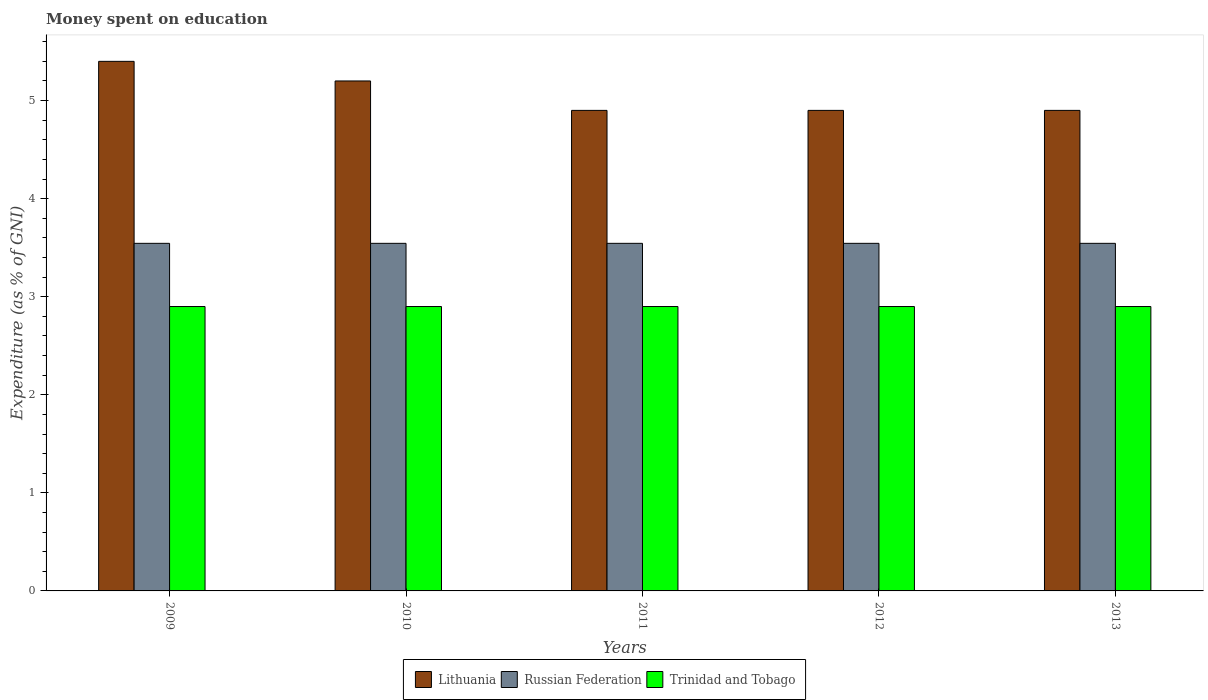How many groups of bars are there?
Offer a very short reply. 5. Are the number of bars on each tick of the X-axis equal?
Your answer should be very brief. Yes. What is the label of the 4th group of bars from the left?
Your response must be concise. 2012. In how many cases, is the number of bars for a given year not equal to the number of legend labels?
Provide a short and direct response. 0. Across all years, what is the maximum amount of money spent on education in Trinidad and Tobago?
Offer a terse response. 2.9. Across all years, what is the minimum amount of money spent on education in Russian Federation?
Ensure brevity in your answer.  3.54. What is the total amount of money spent on education in Trinidad and Tobago in the graph?
Provide a succinct answer. 14.5. What is the difference between the amount of money spent on education in Lithuania in 2010 and that in 2011?
Give a very brief answer. 0.3. What is the difference between the amount of money spent on education in Lithuania in 2010 and the amount of money spent on education in Russian Federation in 2012?
Your answer should be very brief. 1.66. In the year 2013, what is the difference between the amount of money spent on education in Lithuania and amount of money spent on education in Russian Federation?
Offer a terse response. 1.36. In how many years, is the amount of money spent on education in Trinidad and Tobago greater than 3.6 %?
Ensure brevity in your answer.  0. What is the ratio of the amount of money spent on education in Russian Federation in 2011 to that in 2013?
Ensure brevity in your answer.  1. In how many years, is the amount of money spent on education in Lithuania greater than the average amount of money spent on education in Lithuania taken over all years?
Offer a very short reply. 2. Is the sum of the amount of money spent on education in Trinidad and Tobago in 2012 and 2013 greater than the maximum amount of money spent on education in Lithuania across all years?
Keep it short and to the point. Yes. What does the 2nd bar from the left in 2010 represents?
Offer a very short reply. Russian Federation. What does the 3rd bar from the right in 2013 represents?
Your answer should be very brief. Lithuania. How many bars are there?
Ensure brevity in your answer.  15. How many years are there in the graph?
Keep it short and to the point. 5. Are the values on the major ticks of Y-axis written in scientific E-notation?
Give a very brief answer. No. Does the graph contain any zero values?
Your answer should be compact. No. Where does the legend appear in the graph?
Keep it short and to the point. Bottom center. What is the title of the graph?
Keep it short and to the point. Money spent on education. What is the label or title of the Y-axis?
Your response must be concise. Expenditure (as % of GNI). What is the Expenditure (as % of GNI) of Lithuania in 2009?
Offer a very short reply. 5.4. What is the Expenditure (as % of GNI) in Russian Federation in 2009?
Your answer should be very brief. 3.54. What is the Expenditure (as % of GNI) of Trinidad and Tobago in 2009?
Your answer should be compact. 2.9. What is the Expenditure (as % of GNI) in Russian Federation in 2010?
Make the answer very short. 3.54. What is the Expenditure (as % of GNI) in Trinidad and Tobago in 2010?
Offer a terse response. 2.9. What is the Expenditure (as % of GNI) of Lithuania in 2011?
Your answer should be compact. 4.9. What is the Expenditure (as % of GNI) in Russian Federation in 2011?
Your response must be concise. 3.54. What is the Expenditure (as % of GNI) in Russian Federation in 2012?
Provide a succinct answer. 3.54. What is the Expenditure (as % of GNI) of Lithuania in 2013?
Provide a short and direct response. 4.9. What is the Expenditure (as % of GNI) of Russian Federation in 2013?
Provide a succinct answer. 3.54. Across all years, what is the maximum Expenditure (as % of GNI) of Lithuania?
Your answer should be very brief. 5.4. Across all years, what is the maximum Expenditure (as % of GNI) in Russian Federation?
Provide a succinct answer. 3.54. Across all years, what is the minimum Expenditure (as % of GNI) of Russian Federation?
Your answer should be compact. 3.54. What is the total Expenditure (as % of GNI) in Lithuania in the graph?
Your answer should be very brief. 25.3. What is the total Expenditure (as % of GNI) of Russian Federation in the graph?
Provide a short and direct response. 17.72. What is the difference between the Expenditure (as % of GNI) in Russian Federation in 2009 and that in 2011?
Your response must be concise. 0. What is the difference between the Expenditure (as % of GNI) in Trinidad and Tobago in 2009 and that in 2011?
Make the answer very short. 0. What is the difference between the Expenditure (as % of GNI) of Lithuania in 2009 and that in 2012?
Your answer should be compact. 0.5. What is the difference between the Expenditure (as % of GNI) in Trinidad and Tobago in 2009 and that in 2012?
Your answer should be compact. 0. What is the difference between the Expenditure (as % of GNI) in Lithuania in 2009 and that in 2013?
Give a very brief answer. 0.5. What is the difference between the Expenditure (as % of GNI) in Trinidad and Tobago in 2009 and that in 2013?
Keep it short and to the point. 0. What is the difference between the Expenditure (as % of GNI) in Lithuania in 2010 and that in 2011?
Your response must be concise. 0.3. What is the difference between the Expenditure (as % of GNI) of Russian Federation in 2010 and that in 2011?
Make the answer very short. 0. What is the difference between the Expenditure (as % of GNI) of Lithuania in 2010 and that in 2013?
Give a very brief answer. 0.3. What is the difference between the Expenditure (as % of GNI) of Russian Federation in 2010 and that in 2013?
Give a very brief answer. 0. What is the difference between the Expenditure (as % of GNI) of Lithuania in 2011 and that in 2012?
Your answer should be very brief. 0. What is the difference between the Expenditure (as % of GNI) in Russian Federation in 2011 and that in 2012?
Keep it short and to the point. 0. What is the difference between the Expenditure (as % of GNI) of Trinidad and Tobago in 2011 and that in 2012?
Provide a short and direct response. 0. What is the difference between the Expenditure (as % of GNI) of Russian Federation in 2011 and that in 2013?
Ensure brevity in your answer.  0. What is the difference between the Expenditure (as % of GNI) of Trinidad and Tobago in 2011 and that in 2013?
Keep it short and to the point. 0. What is the difference between the Expenditure (as % of GNI) of Russian Federation in 2012 and that in 2013?
Ensure brevity in your answer.  0. What is the difference between the Expenditure (as % of GNI) of Trinidad and Tobago in 2012 and that in 2013?
Provide a succinct answer. 0. What is the difference between the Expenditure (as % of GNI) in Lithuania in 2009 and the Expenditure (as % of GNI) in Russian Federation in 2010?
Offer a very short reply. 1.86. What is the difference between the Expenditure (as % of GNI) of Russian Federation in 2009 and the Expenditure (as % of GNI) of Trinidad and Tobago in 2010?
Ensure brevity in your answer.  0.64. What is the difference between the Expenditure (as % of GNI) in Lithuania in 2009 and the Expenditure (as % of GNI) in Russian Federation in 2011?
Make the answer very short. 1.86. What is the difference between the Expenditure (as % of GNI) of Lithuania in 2009 and the Expenditure (as % of GNI) of Trinidad and Tobago in 2011?
Offer a very short reply. 2.5. What is the difference between the Expenditure (as % of GNI) in Russian Federation in 2009 and the Expenditure (as % of GNI) in Trinidad and Tobago in 2011?
Provide a short and direct response. 0.64. What is the difference between the Expenditure (as % of GNI) in Lithuania in 2009 and the Expenditure (as % of GNI) in Russian Federation in 2012?
Offer a very short reply. 1.86. What is the difference between the Expenditure (as % of GNI) in Lithuania in 2009 and the Expenditure (as % of GNI) in Trinidad and Tobago in 2012?
Your response must be concise. 2.5. What is the difference between the Expenditure (as % of GNI) in Russian Federation in 2009 and the Expenditure (as % of GNI) in Trinidad and Tobago in 2012?
Provide a succinct answer. 0.64. What is the difference between the Expenditure (as % of GNI) in Lithuania in 2009 and the Expenditure (as % of GNI) in Russian Federation in 2013?
Offer a terse response. 1.86. What is the difference between the Expenditure (as % of GNI) in Russian Federation in 2009 and the Expenditure (as % of GNI) in Trinidad and Tobago in 2013?
Make the answer very short. 0.64. What is the difference between the Expenditure (as % of GNI) in Lithuania in 2010 and the Expenditure (as % of GNI) in Russian Federation in 2011?
Your answer should be compact. 1.66. What is the difference between the Expenditure (as % of GNI) in Lithuania in 2010 and the Expenditure (as % of GNI) in Trinidad and Tobago in 2011?
Give a very brief answer. 2.3. What is the difference between the Expenditure (as % of GNI) of Russian Federation in 2010 and the Expenditure (as % of GNI) of Trinidad and Tobago in 2011?
Ensure brevity in your answer.  0.64. What is the difference between the Expenditure (as % of GNI) in Lithuania in 2010 and the Expenditure (as % of GNI) in Russian Federation in 2012?
Give a very brief answer. 1.66. What is the difference between the Expenditure (as % of GNI) in Lithuania in 2010 and the Expenditure (as % of GNI) in Trinidad and Tobago in 2012?
Offer a very short reply. 2.3. What is the difference between the Expenditure (as % of GNI) of Russian Federation in 2010 and the Expenditure (as % of GNI) of Trinidad and Tobago in 2012?
Provide a succinct answer. 0.64. What is the difference between the Expenditure (as % of GNI) of Lithuania in 2010 and the Expenditure (as % of GNI) of Russian Federation in 2013?
Give a very brief answer. 1.66. What is the difference between the Expenditure (as % of GNI) in Lithuania in 2010 and the Expenditure (as % of GNI) in Trinidad and Tobago in 2013?
Your answer should be very brief. 2.3. What is the difference between the Expenditure (as % of GNI) of Russian Federation in 2010 and the Expenditure (as % of GNI) of Trinidad and Tobago in 2013?
Give a very brief answer. 0.64. What is the difference between the Expenditure (as % of GNI) of Lithuania in 2011 and the Expenditure (as % of GNI) of Russian Federation in 2012?
Ensure brevity in your answer.  1.36. What is the difference between the Expenditure (as % of GNI) of Russian Federation in 2011 and the Expenditure (as % of GNI) of Trinidad and Tobago in 2012?
Your response must be concise. 0.64. What is the difference between the Expenditure (as % of GNI) of Lithuania in 2011 and the Expenditure (as % of GNI) of Russian Federation in 2013?
Keep it short and to the point. 1.36. What is the difference between the Expenditure (as % of GNI) of Lithuania in 2011 and the Expenditure (as % of GNI) of Trinidad and Tobago in 2013?
Your response must be concise. 2. What is the difference between the Expenditure (as % of GNI) in Russian Federation in 2011 and the Expenditure (as % of GNI) in Trinidad and Tobago in 2013?
Offer a very short reply. 0.64. What is the difference between the Expenditure (as % of GNI) in Lithuania in 2012 and the Expenditure (as % of GNI) in Russian Federation in 2013?
Your answer should be very brief. 1.36. What is the difference between the Expenditure (as % of GNI) in Russian Federation in 2012 and the Expenditure (as % of GNI) in Trinidad and Tobago in 2013?
Provide a short and direct response. 0.64. What is the average Expenditure (as % of GNI) of Lithuania per year?
Provide a succinct answer. 5.06. What is the average Expenditure (as % of GNI) in Russian Federation per year?
Offer a terse response. 3.54. In the year 2009, what is the difference between the Expenditure (as % of GNI) of Lithuania and Expenditure (as % of GNI) of Russian Federation?
Offer a terse response. 1.86. In the year 2009, what is the difference between the Expenditure (as % of GNI) in Russian Federation and Expenditure (as % of GNI) in Trinidad and Tobago?
Ensure brevity in your answer.  0.64. In the year 2010, what is the difference between the Expenditure (as % of GNI) of Lithuania and Expenditure (as % of GNI) of Russian Federation?
Your answer should be compact. 1.66. In the year 2010, what is the difference between the Expenditure (as % of GNI) in Lithuania and Expenditure (as % of GNI) in Trinidad and Tobago?
Give a very brief answer. 2.3. In the year 2010, what is the difference between the Expenditure (as % of GNI) of Russian Federation and Expenditure (as % of GNI) of Trinidad and Tobago?
Your answer should be compact. 0.64. In the year 2011, what is the difference between the Expenditure (as % of GNI) of Lithuania and Expenditure (as % of GNI) of Russian Federation?
Offer a very short reply. 1.36. In the year 2011, what is the difference between the Expenditure (as % of GNI) in Lithuania and Expenditure (as % of GNI) in Trinidad and Tobago?
Your answer should be very brief. 2. In the year 2011, what is the difference between the Expenditure (as % of GNI) of Russian Federation and Expenditure (as % of GNI) of Trinidad and Tobago?
Ensure brevity in your answer.  0.64. In the year 2012, what is the difference between the Expenditure (as % of GNI) of Lithuania and Expenditure (as % of GNI) of Russian Federation?
Give a very brief answer. 1.36. In the year 2012, what is the difference between the Expenditure (as % of GNI) in Lithuania and Expenditure (as % of GNI) in Trinidad and Tobago?
Offer a terse response. 2. In the year 2012, what is the difference between the Expenditure (as % of GNI) in Russian Federation and Expenditure (as % of GNI) in Trinidad and Tobago?
Provide a succinct answer. 0.64. In the year 2013, what is the difference between the Expenditure (as % of GNI) of Lithuania and Expenditure (as % of GNI) of Russian Federation?
Your response must be concise. 1.36. In the year 2013, what is the difference between the Expenditure (as % of GNI) in Lithuania and Expenditure (as % of GNI) in Trinidad and Tobago?
Ensure brevity in your answer.  2. In the year 2013, what is the difference between the Expenditure (as % of GNI) in Russian Federation and Expenditure (as % of GNI) in Trinidad and Tobago?
Provide a succinct answer. 0.64. What is the ratio of the Expenditure (as % of GNI) in Russian Federation in 2009 to that in 2010?
Keep it short and to the point. 1. What is the ratio of the Expenditure (as % of GNI) of Lithuania in 2009 to that in 2011?
Your answer should be very brief. 1.1. What is the ratio of the Expenditure (as % of GNI) of Russian Federation in 2009 to that in 2011?
Offer a terse response. 1. What is the ratio of the Expenditure (as % of GNI) of Lithuania in 2009 to that in 2012?
Give a very brief answer. 1.1. What is the ratio of the Expenditure (as % of GNI) in Russian Federation in 2009 to that in 2012?
Provide a short and direct response. 1. What is the ratio of the Expenditure (as % of GNI) of Lithuania in 2009 to that in 2013?
Give a very brief answer. 1.1. What is the ratio of the Expenditure (as % of GNI) of Trinidad and Tobago in 2009 to that in 2013?
Keep it short and to the point. 1. What is the ratio of the Expenditure (as % of GNI) of Lithuania in 2010 to that in 2011?
Ensure brevity in your answer.  1.06. What is the ratio of the Expenditure (as % of GNI) of Russian Federation in 2010 to that in 2011?
Offer a very short reply. 1. What is the ratio of the Expenditure (as % of GNI) of Lithuania in 2010 to that in 2012?
Offer a very short reply. 1.06. What is the ratio of the Expenditure (as % of GNI) of Russian Federation in 2010 to that in 2012?
Give a very brief answer. 1. What is the ratio of the Expenditure (as % of GNI) in Trinidad and Tobago in 2010 to that in 2012?
Ensure brevity in your answer.  1. What is the ratio of the Expenditure (as % of GNI) in Lithuania in 2010 to that in 2013?
Your answer should be compact. 1.06. What is the ratio of the Expenditure (as % of GNI) of Trinidad and Tobago in 2010 to that in 2013?
Ensure brevity in your answer.  1. What is the ratio of the Expenditure (as % of GNI) of Lithuania in 2011 to that in 2012?
Give a very brief answer. 1. What is the ratio of the Expenditure (as % of GNI) in Trinidad and Tobago in 2011 to that in 2012?
Your answer should be compact. 1. What is the ratio of the Expenditure (as % of GNI) in Trinidad and Tobago in 2011 to that in 2013?
Your answer should be compact. 1. What is the difference between the highest and the second highest Expenditure (as % of GNI) in Lithuania?
Keep it short and to the point. 0.2. What is the difference between the highest and the second highest Expenditure (as % of GNI) in Russian Federation?
Make the answer very short. 0. What is the difference between the highest and the lowest Expenditure (as % of GNI) of Trinidad and Tobago?
Your response must be concise. 0. 